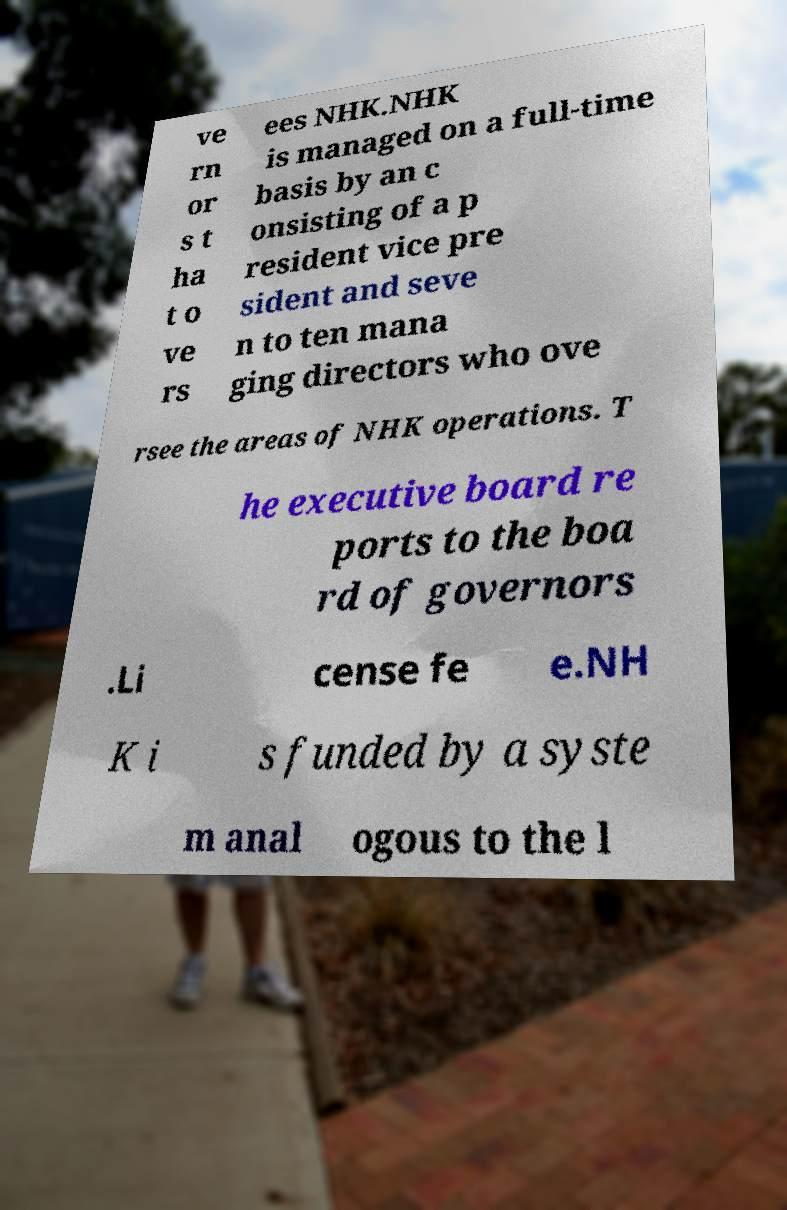Could you assist in decoding the text presented in this image and type it out clearly? ve rn or s t ha t o ve rs ees NHK.NHK is managed on a full-time basis by an c onsisting of a p resident vice pre sident and seve n to ten mana ging directors who ove rsee the areas of NHK operations. T he executive board re ports to the boa rd of governors .Li cense fe e.NH K i s funded by a syste m anal ogous to the l 